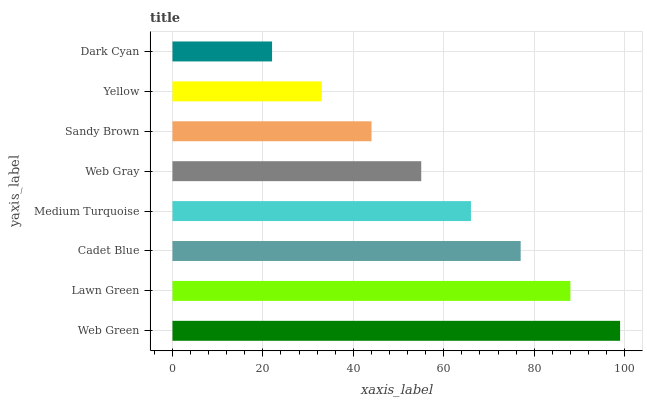Is Dark Cyan the minimum?
Answer yes or no. Yes. Is Web Green the maximum?
Answer yes or no. Yes. Is Lawn Green the minimum?
Answer yes or no. No. Is Lawn Green the maximum?
Answer yes or no. No. Is Web Green greater than Lawn Green?
Answer yes or no. Yes. Is Lawn Green less than Web Green?
Answer yes or no. Yes. Is Lawn Green greater than Web Green?
Answer yes or no. No. Is Web Green less than Lawn Green?
Answer yes or no. No. Is Medium Turquoise the high median?
Answer yes or no. Yes. Is Web Gray the low median?
Answer yes or no. Yes. Is Web Green the high median?
Answer yes or no. No. Is Lawn Green the low median?
Answer yes or no. No. 